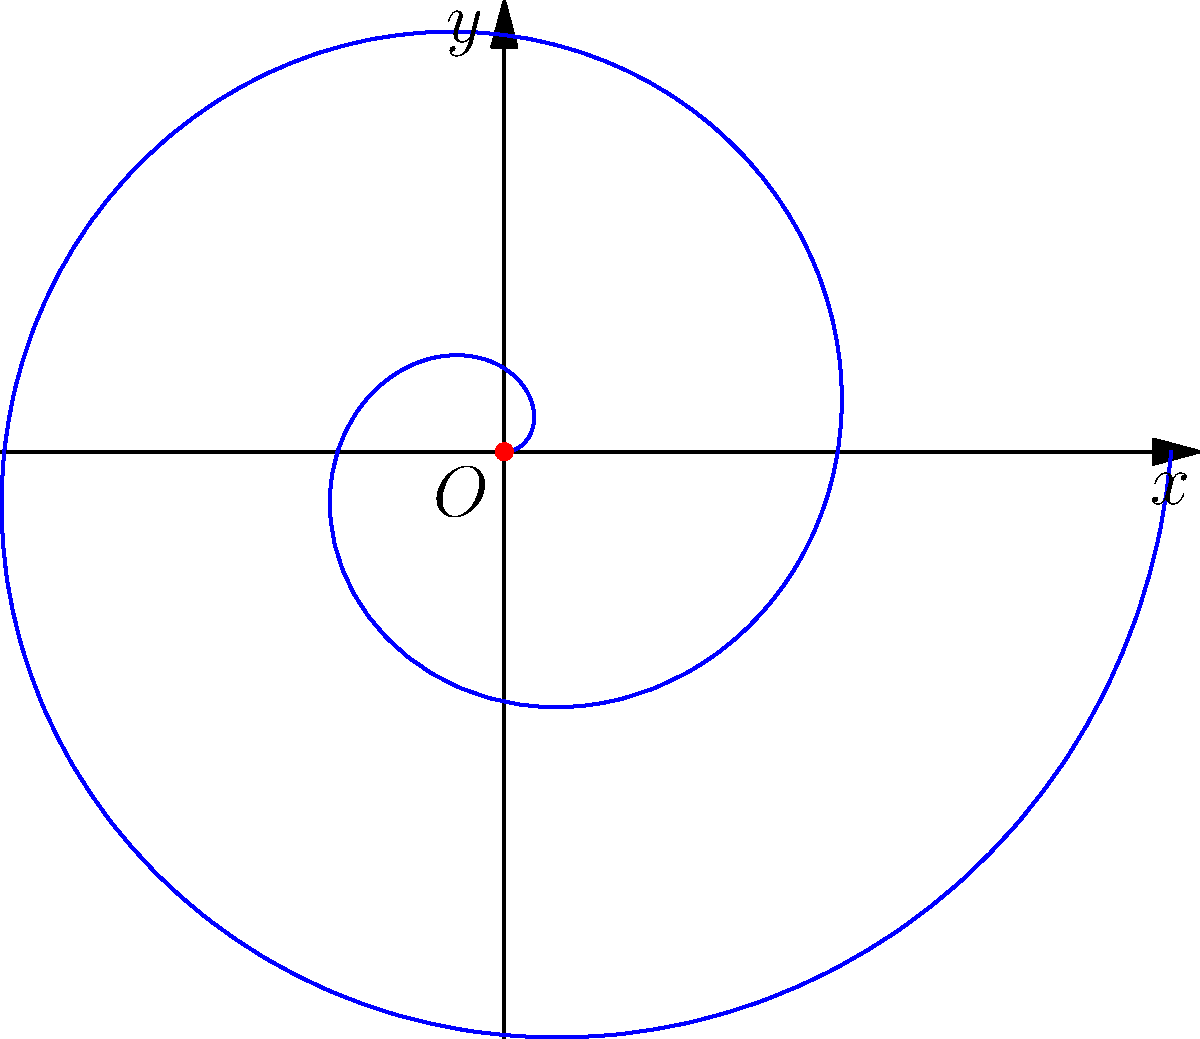In the spiral of Archimedes shown above, which is described by the polar equation $r = a\theta$, what is the relationship between the radial distance $r$ and the polar angle $\theta$ as the spiral makes one complete revolution? To understand the relationship between $r$ and $\theta$ in the spiral of Archimedes, let's follow these steps:

1) The general equation for the spiral of Archimedes is $r = a\theta$, where $a$ is a constant that determines how tightly the spiral is wound.

2) One complete revolution corresponds to an angle of $2\pi$ radians.

3) At the start of the revolution ($\theta = 0$), $r = a \cdot 0 = 0$.

4) At the end of one revolution ($\theta = 2\pi$), $r = a \cdot 2\pi$.

5) This means that for every increase of $2\pi$ in $\theta$, $r$ increases by $2\pi a$.

6) The relationship is linear: as $\theta$ increases uniformly, $r$ also increases uniformly.

7) Visually, this results in equally spaced turnings of the spiral, where the distance between successive turnings (measured along any straight line from the origin) is constant and equal to $2\pi a$.

Therefore, the radial distance $r$ increases linearly with the polar angle $\theta$, resulting in a constant separation between successive turnings of the spiral.
Answer: $r$ increases linearly with $\theta$, with constant separation $2\pi a$ between successive turnings. 